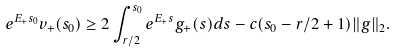<formula> <loc_0><loc_0><loc_500><loc_500>e ^ { E _ { + } s _ { 0 } } v _ { + } ( s _ { 0 } ) \geq 2 \int _ { r / 2 } ^ { s _ { 0 } } e ^ { E _ { + } s } g _ { + } ( s ) d s - c ( s _ { 0 } - r / 2 + 1 ) \| g \| _ { 2 } .</formula> 